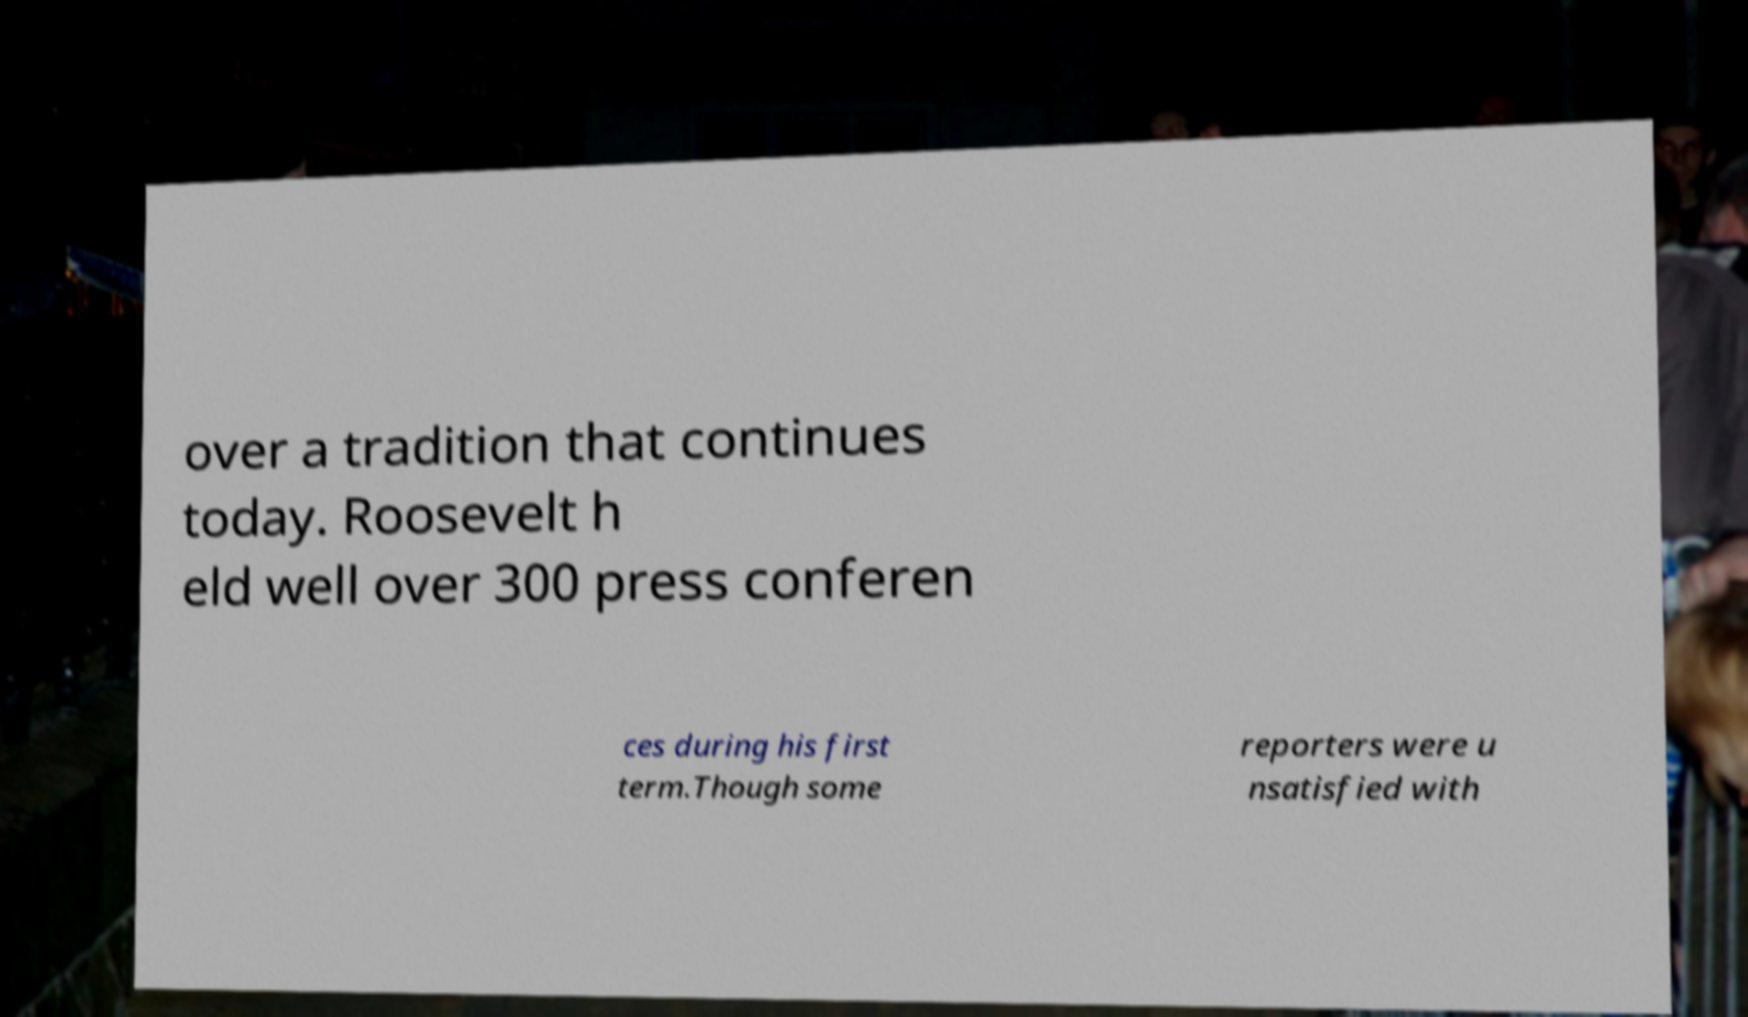What messages or text are displayed in this image? I need them in a readable, typed format. over a tradition that continues today. Roosevelt h eld well over 300 press conferen ces during his first term.Though some reporters were u nsatisfied with 